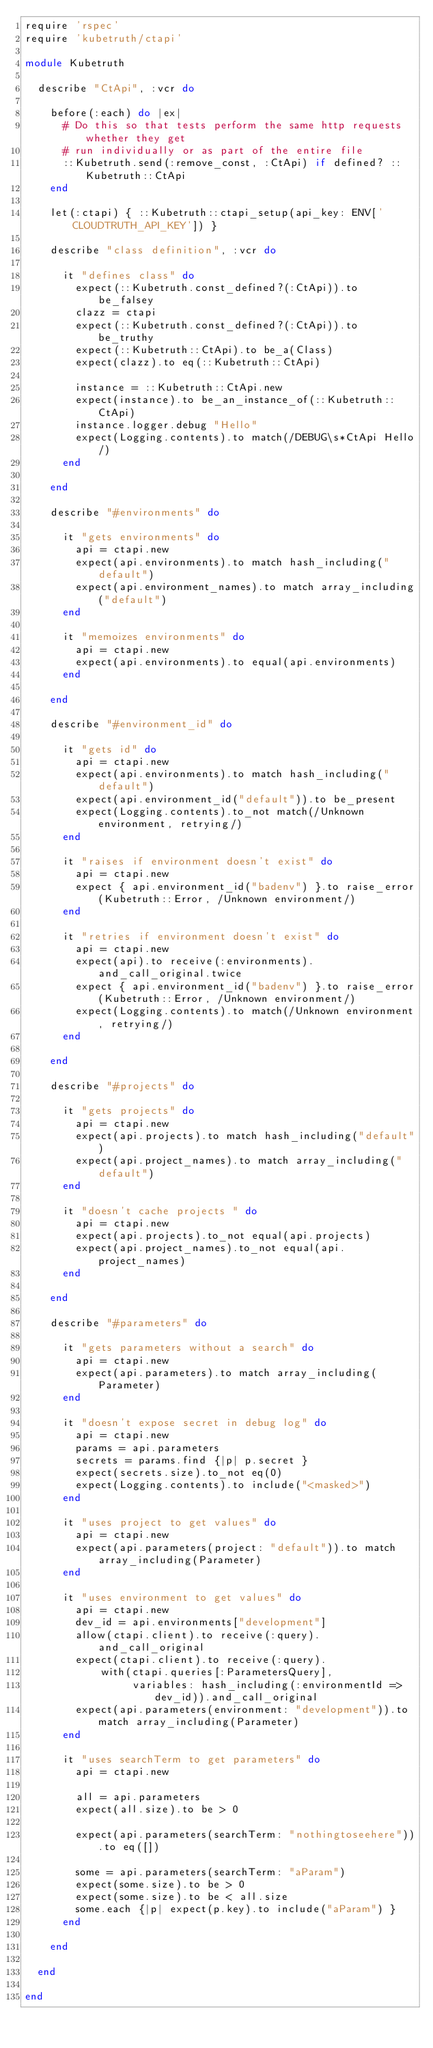<code> <loc_0><loc_0><loc_500><loc_500><_Ruby_>require 'rspec'
require 'kubetruth/ctapi'

module Kubetruth

  describe "CtApi", :vcr do

    before(:each) do |ex|
      # Do this so that tests perform the same http requests whether they get
      # run individually or as part of the entire file
      ::Kubetruth.send(:remove_const, :CtApi) if defined? ::Kubetruth::CtApi
    end

    let(:ctapi) { ::Kubetruth::ctapi_setup(api_key: ENV['CLOUDTRUTH_API_KEY']) }

    describe "class definition", :vcr do

      it "defines class" do
        expect(::Kubetruth.const_defined?(:CtApi)).to be_falsey
        clazz = ctapi
        expect(::Kubetruth.const_defined?(:CtApi)).to be_truthy
        expect(::Kubetruth::CtApi).to be_a(Class)
        expect(clazz).to eq(::Kubetruth::CtApi)

        instance = ::Kubetruth::CtApi.new
        expect(instance).to be_an_instance_of(::Kubetruth::CtApi)
        instance.logger.debug "Hello"
        expect(Logging.contents).to match(/DEBUG\s*CtApi Hello/)
      end

    end

    describe "#environments" do

      it "gets environments" do
        api = ctapi.new
        expect(api.environments).to match hash_including("default")
        expect(api.environment_names).to match array_including("default")
      end

      it "memoizes environments" do
        api = ctapi.new
        expect(api.environments).to equal(api.environments)
      end

    end

    describe "#environment_id" do

      it "gets id" do
        api = ctapi.new
        expect(api.environments).to match hash_including("default")
        expect(api.environment_id("default")).to be_present
        expect(Logging.contents).to_not match(/Unknown environment, retrying/)
      end

      it "raises if environment doesn't exist" do
        api = ctapi.new
        expect { api.environment_id("badenv") }.to raise_error(Kubetruth::Error, /Unknown environment/)
      end

      it "retries if environment doesn't exist" do
        api = ctapi.new
        expect(api).to receive(:environments).and_call_original.twice
        expect { api.environment_id("badenv") }.to raise_error(Kubetruth::Error, /Unknown environment/)
        expect(Logging.contents).to match(/Unknown environment, retrying/)
      end

    end

    describe "#projects" do

      it "gets projects" do
        api = ctapi.new
        expect(api.projects).to match hash_including("default")
        expect(api.project_names).to match array_including("default")
      end

      it "doesn't cache projects " do
        api = ctapi.new
        expect(api.projects).to_not equal(api.projects)
        expect(api.project_names).to_not equal(api.project_names)
      end

    end

    describe "#parameters" do

      it "gets parameters without a search" do
        api = ctapi.new
        expect(api.parameters).to match array_including(Parameter)
      end

      it "doesn't expose secret in debug log" do
        api = ctapi.new
        params = api.parameters
        secrets = params.find {|p| p.secret }
        expect(secrets.size).to_not eq(0)
        expect(Logging.contents).to include("<masked>")
      end

      it "uses project to get values" do
        api = ctapi.new
        expect(api.parameters(project: "default")).to match array_including(Parameter)
      end

      it "uses environment to get values" do
        api = ctapi.new
        dev_id = api.environments["development"]
        allow(ctapi.client).to receive(:query).and_call_original
        expect(ctapi.client).to receive(:query).
            with(ctapi.queries[:ParametersQuery],
                 variables: hash_including(:environmentId => dev_id)).and_call_original
        expect(api.parameters(environment: "development")).to match array_including(Parameter)
      end

      it "uses searchTerm to get parameters" do
        api = ctapi.new

        all = api.parameters
        expect(all.size).to be > 0

        expect(api.parameters(searchTerm: "nothingtoseehere")).to eq([])

        some = api.parameters(searchTerm: "aParam")
        expect(some.size).to be > 0
        expect(some.size).to be < all.size
        some.each {|p| expect(p.key).to include("aParam") }
      end

    end

  end

end
</code> 